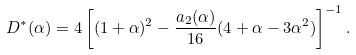Convert formula to latex. <formula><loc_0><loc_0><loc_500><loc_500>D ^ { * } ( \alpha ) = 4 \left [ ( 1 + \alpha ) ^ { 2 } - \frac { a _ { 2 } ( \alpha ) } { 1 6 } ( 4 + \alpha - 3 \alpha ^ { 2 } ) \right ] ^ { - 1 } .</formula> 